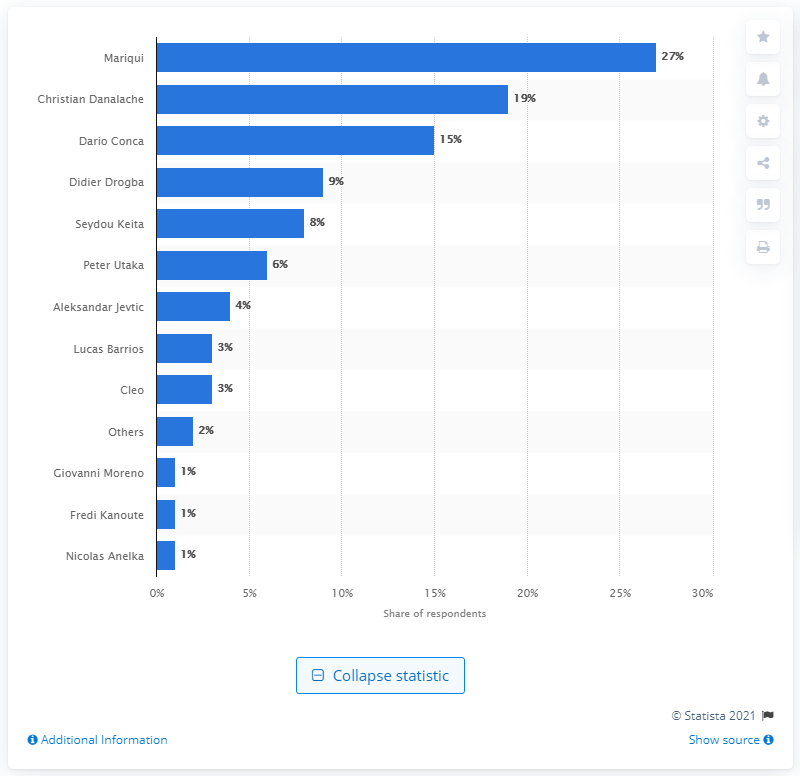List a handful of essential elements in this visual. Dario Conca was the most successful overseas player in the Chinese Super League. 